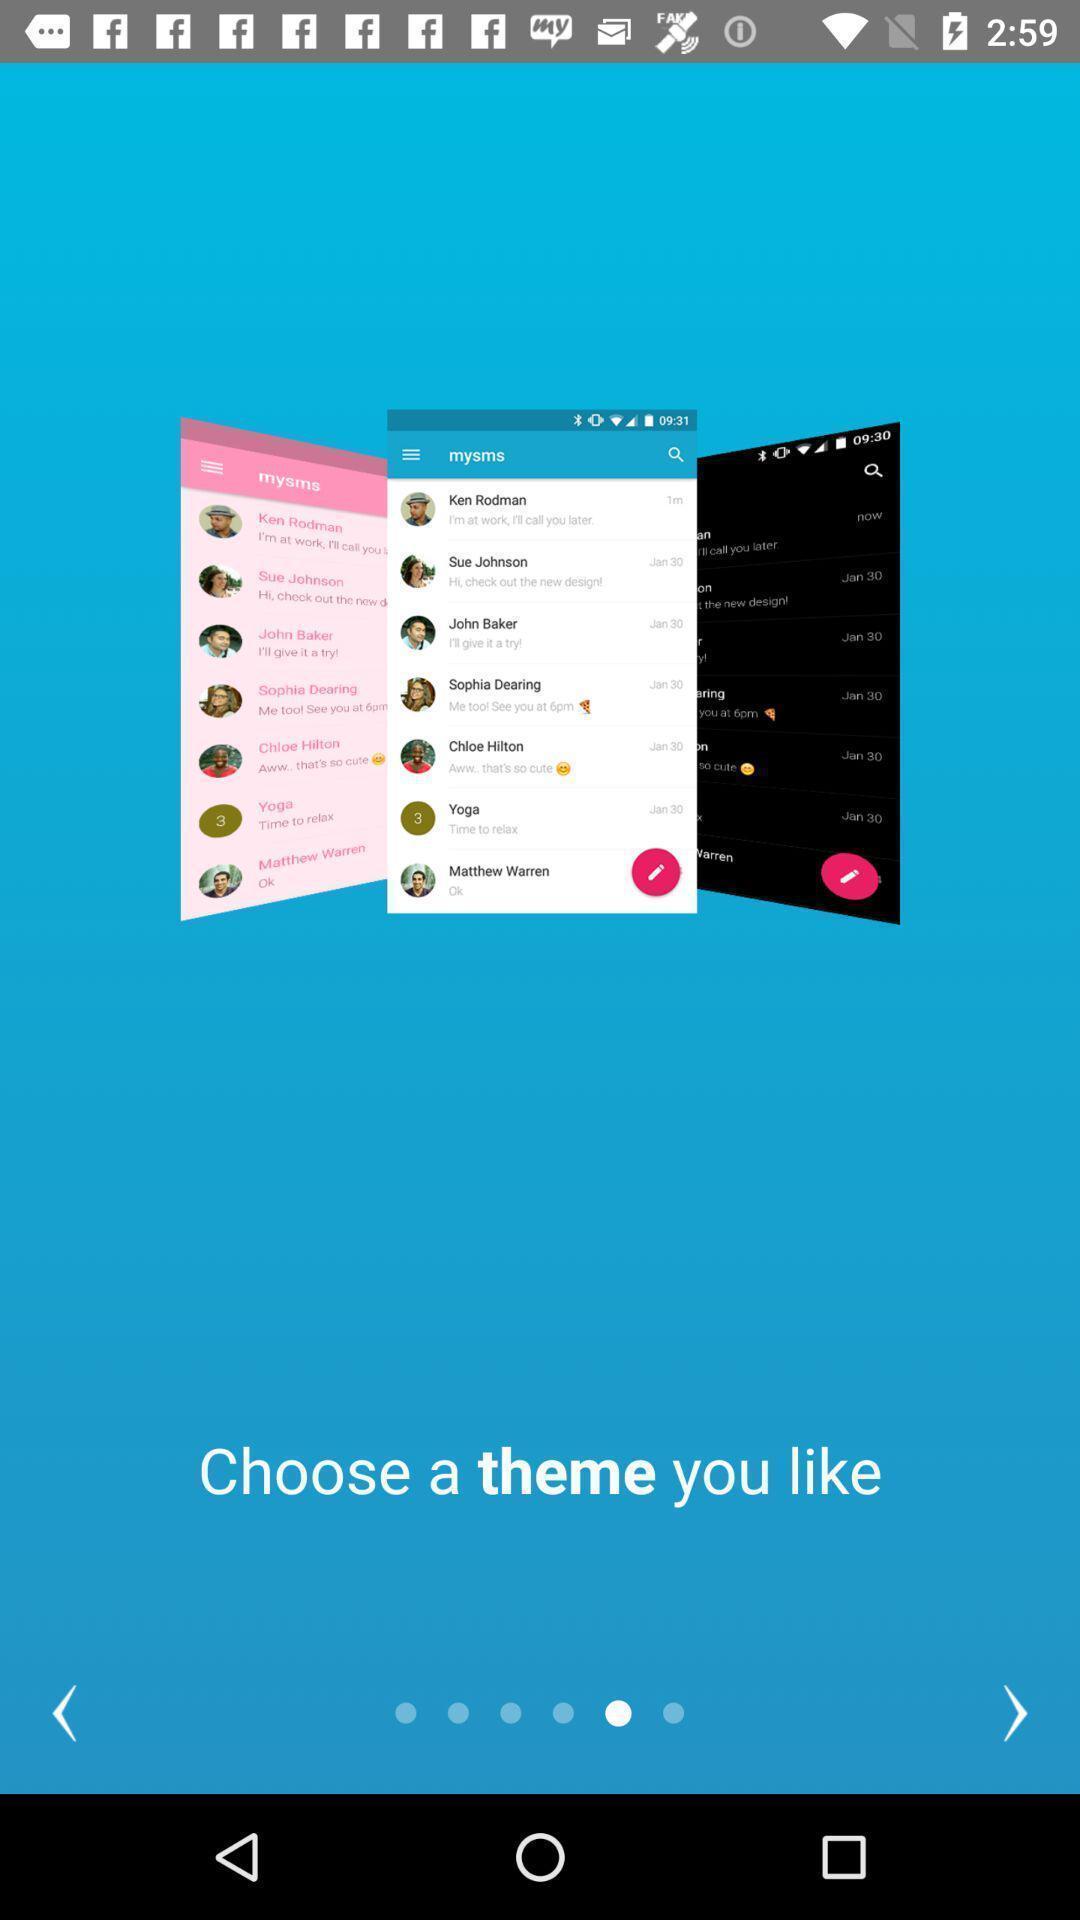Give me a narrative description of this picture. Welcome page displayed to choose a theme. 